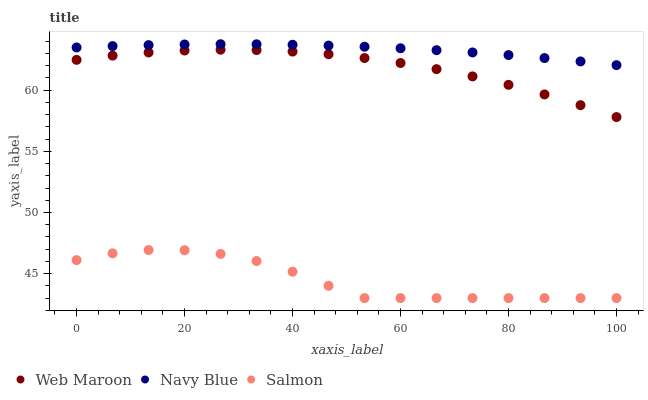Does Salmon have the minimum area under the curve?
Answer yes or no. Yes. Does Navy Blue have the maximum area under the curve?
Answer yes or no. Yes. Does Web Maroon have the minimum area under the curve?
Answer yes or no. No. Does Web Maroon have the maximum area under the curve?
Answer yes or no. No. Is Navy Blue the smoothest?
Answer yes or no. Yes. Is Salmon the roughest?
Answer yes or no. Yes. Is Web Maroon the smoothest?
Answer yes or no. No. Is Web Maroon the roughest?
Answer yes or no. No. Does Salmon have the lowest value?
Answer yes or no. Yes. Does Web Maroon have the lowest value?
Answer yes or no. No. Does Navy Blue have the highest value?
Answer yes or no. Yes. Does Web Maroon have the highest value?
Answer yes or no. No. Is Salmon less than Web Maroon?
Answer yes or no. Yes. Is Navy Blue greater than Salmon?
Answer yes or no. Yes. Does Salmon intersect Web Maroon?
Answer yes or no. No. 